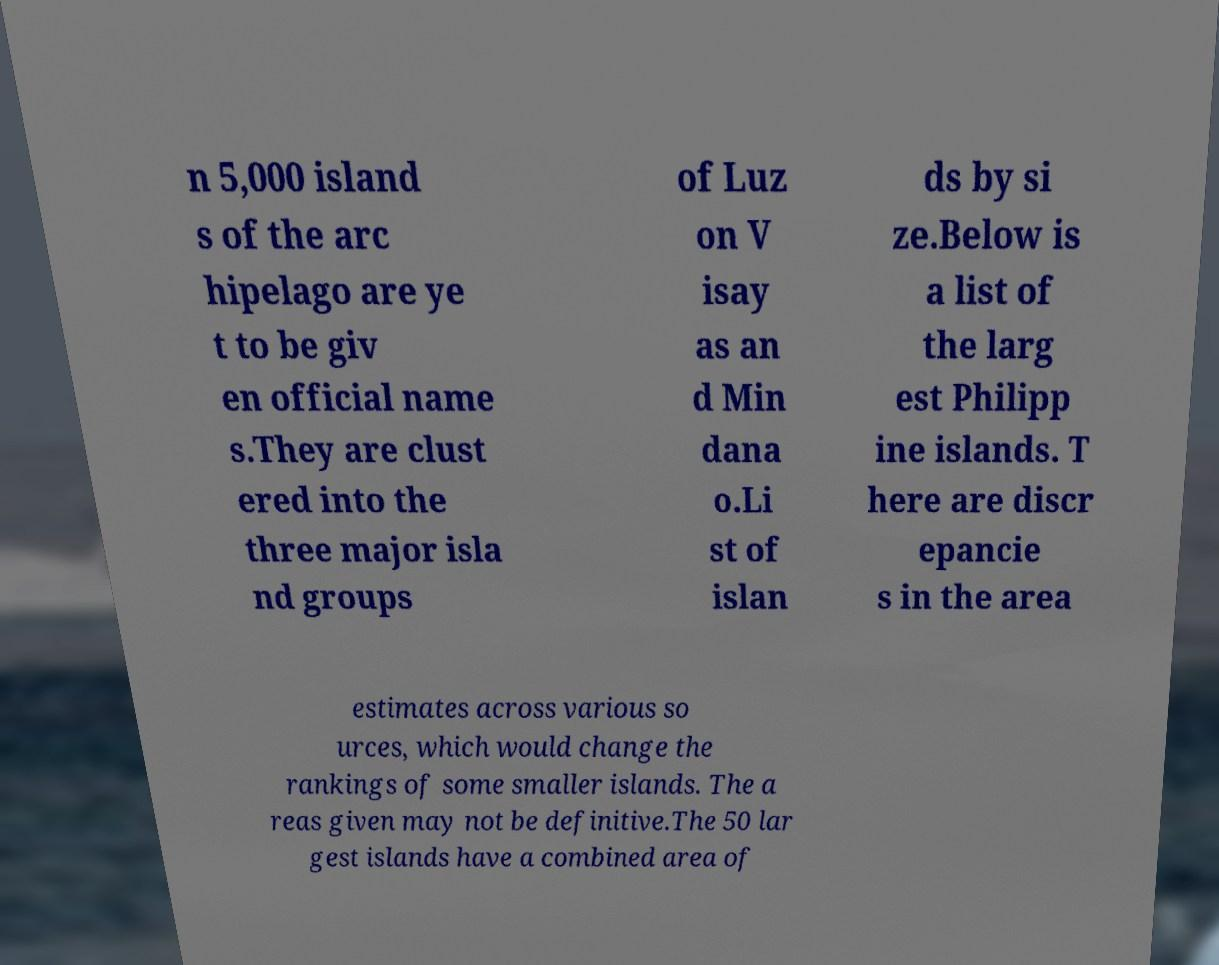I need the written content from this picture converted into text. Can you do that? n 5,000 island s of the arc hipelago are ye t to be giv en official name s.They are clust ered into the three major isla nd groups of Luz on V isay as an d Min dana o.Li st of islan ds by si ze.Below is a list of the larg est Philipp ine islands. T here are discr epancie s in the area estimates across various so urces, which would change the rankings of some smaller islands. The a reas given may not be definitive.The 50 lar gest islands have a combined area of 